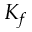Convert formula to latex. <formula><loc_0><loc_0><loc_500><loc_500>K _ { f }</formula> 